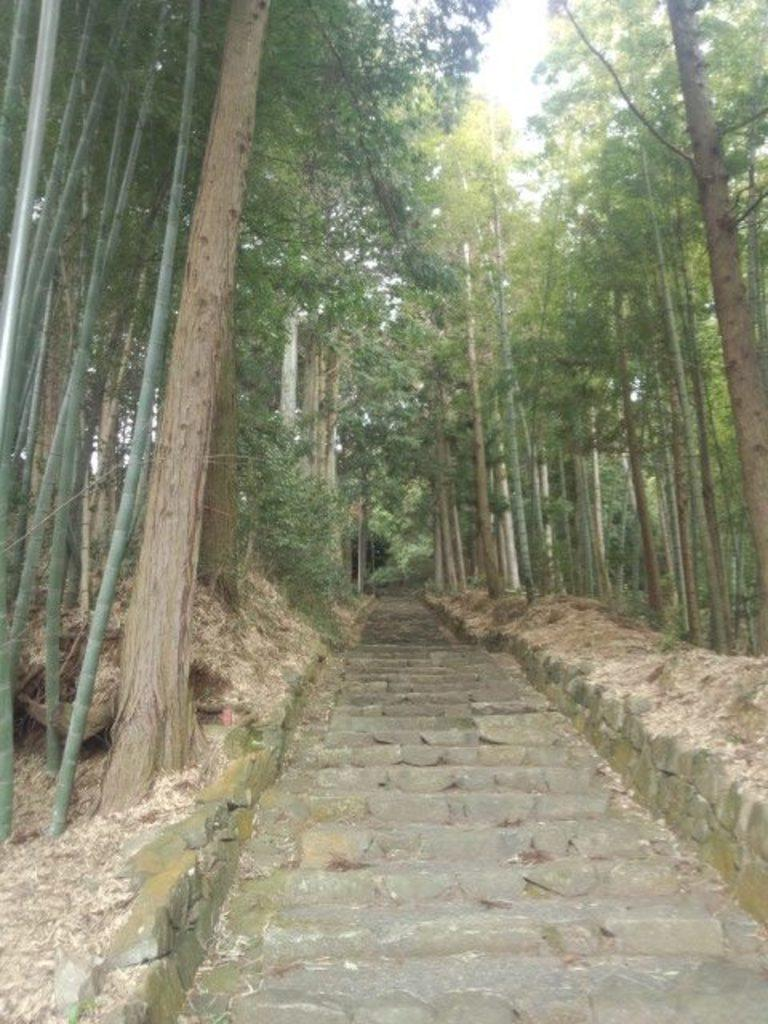What structure is located in the middle of the image? There are stairs in the middle of the image. What type of vegetation is on the left side of the image? There are trees on the left side of the image. What type of vegetation is on the right side of the image? There are trees on the right side of the image. What is visible at the top of the image? The sky is visible at the top of the image. Can you tell me how many times the bulb sneezes in the image? There is no bulb or sneezing in the image; it features stairs, trees, and the sky. What type of offer is being made by the trees in the image? There is no offer being made by the trees in the image; they are simply vegetation in the background. 